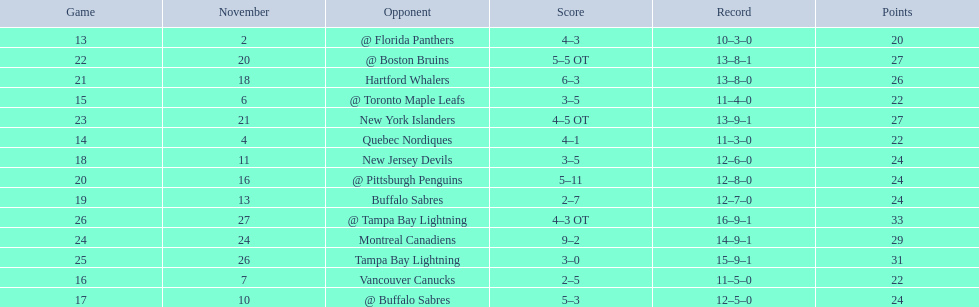Did the tampa bay lightning have the least amount of wins? Yes. 